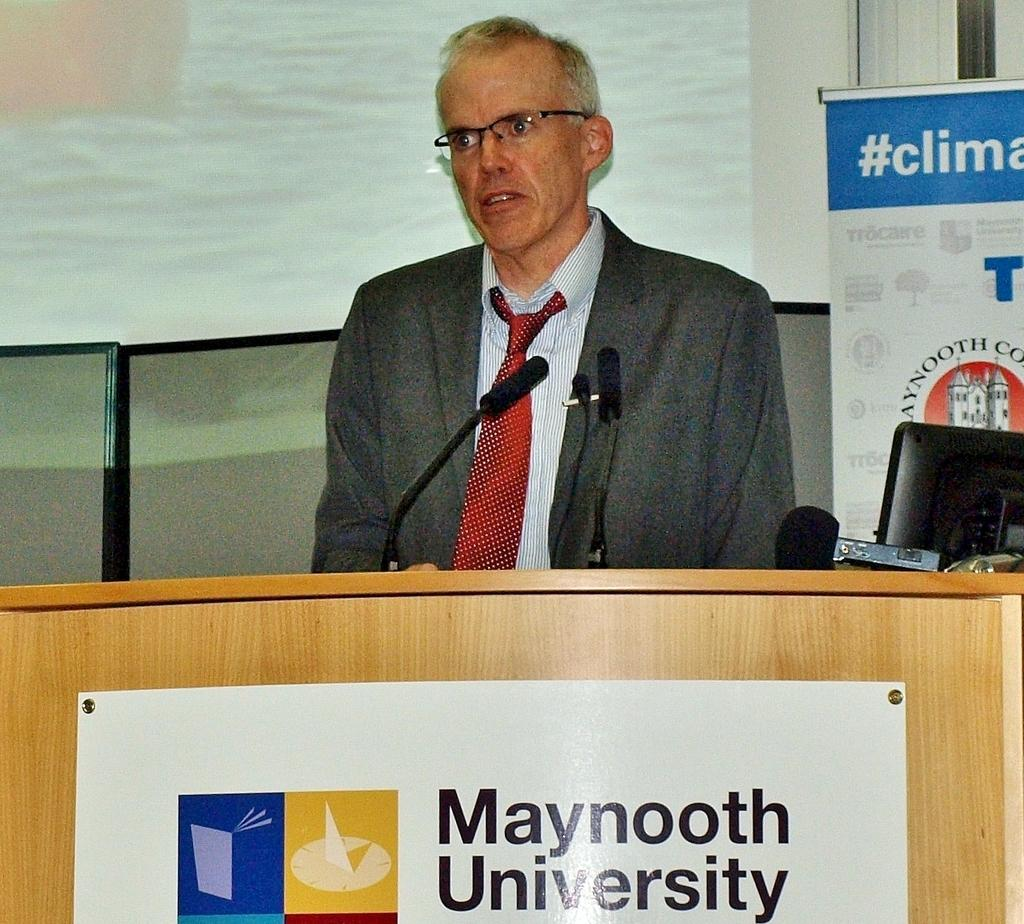<image>
Give a short and clear explanation of the subsequent image. Man in a suit standing by a podium for maynooth university. 